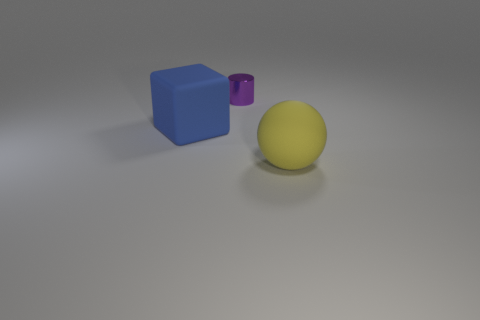How do the shadows cast by the objects relate to their shapes? The shadows in the image are consistent with the shapes of the objects and the presumed light source position. The blue cube casts a sharp-edged shadow that matches its square form, while the yellow sphere casts a rounded shadow. The purple cylinder's shadow is elongated, again consistent with its cylindrical shape. This indicates a single light source to the upper left of the frame. 